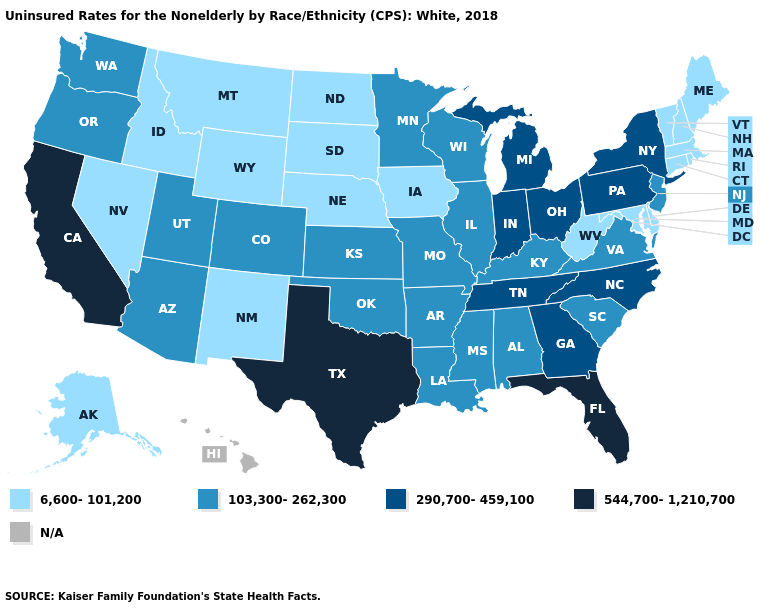Is the legend a continuous bar?
Write a very short answer. No. Is the legend a continuous bar?
Short answer required. No. What is the value of Louisiana?
Concise answer only. 103,300-262,300. Name the states that have a value in the range 290,700-459,100?
Answer briefly. Georgia, Indiana, Michigan, New York, North Carolina, Ohio, Pennsylvania, Tennessee. Which states have the highest value in the USA?
Quick response, please. California, Florida, Texas. What is the highest value in the West ?
Write a very short answer. 544,700-1,210,700. Which states hav the highest value in the West?
Short answer required. California. What is the highest value in states that border Tennessee?
Concise answer only. 290,700-459,100. Does the map have missing data?
Give a very brief answer. Yes. Name the states that have a value in the range 544,700-1,210,700?
Keep it brief. California, Florida, Texas. What is the value of Nebraska?
Concise answer only. 6,600-101,200. Name the states that have a value in the range N/A?
Concise answer only. Hawaii. Name the states that have a value in the range 290,700-459,100?
Write a very short answer. Georgia, Indiana, Michigan, New York, North Carolina, Ohio, Pennsylvania, Tennessee. Which states have the highest value in the USA?
Be succinct. California, Florida, Texas. What is the value of Missouri?
Quick response, please. 103,300-262,300. 